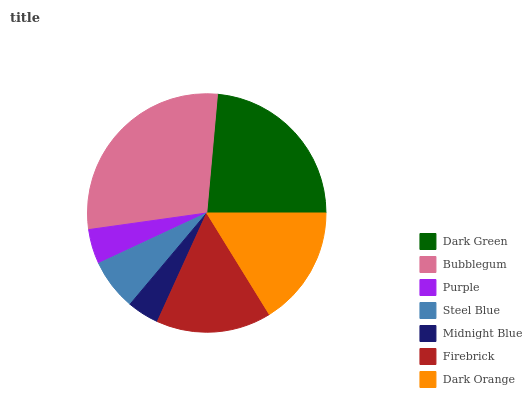Is Midnight Blue the minimum?
Answer yes or no. Yes. Is Bubblegum the maximum?
Answer yes or no. Yes. Is Purple the minimum?
Answer yes or no. No. Is Purple the maximum?
Answer yes or no. No. Is Bubblegum greater than Purple?
Answer yes or no. Yes. Is Purple less than Bubblegum?
Answer yes or no. Yes. Is Purple greater than Bubblegum?
Answer yes or no. No. Is Bubblegum less than Purple?
Answer yes or no. No. Is Firebrick the high median?
Answer yes or no. Yes. Is Firebrick the low median?
Answer yes or no. Yes. Is Purple the high median?
Answer yes or no. No. Is Dark Orange the low median?
Answer yes or no. No. 